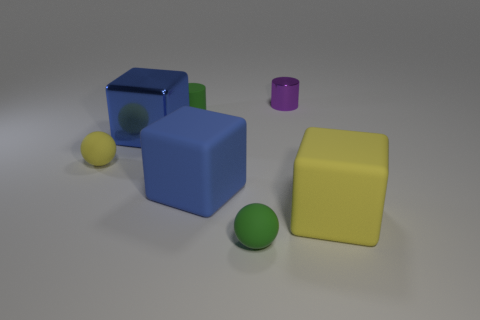What is the size of the rubber object that is the same color as the tiny matte cylinder?
Give a very brief answer. Small. What shape is the tiny green rubber thing that is behind the tiny green matte ball?
Ensure brevity in your answer.  Cylinder. Is there another block that has the same material as the yellow block?
Ensure brevity in your answer.  Yes. There is a ball to the right of the yellow ball; is it the same color as the small rubber cylinder?
Offer a terse response. Yes. What is the size of the purple metal cylinder?
Provide a succinct answer. Small. There is a small sphere that is right of the small rubber ball that is behind the yellow cube; are there any green rubber things that are on the right side of it?
Give a very brief answer. No. There is a small yellow ball; what number of small green matte cylinders are behind it?
Provide a succinct answer. 1. How many rubber cylinders have the same color as the small metallic thing?
Ensure brevity in your answer.  0. How many things are small objects behind the large metallic object or tiny spheres behind the large yellow rubber cube?
Your answer should be compact. 3. Are there more metal cylinders than big blue cubes?
Your response must be concise. No. 